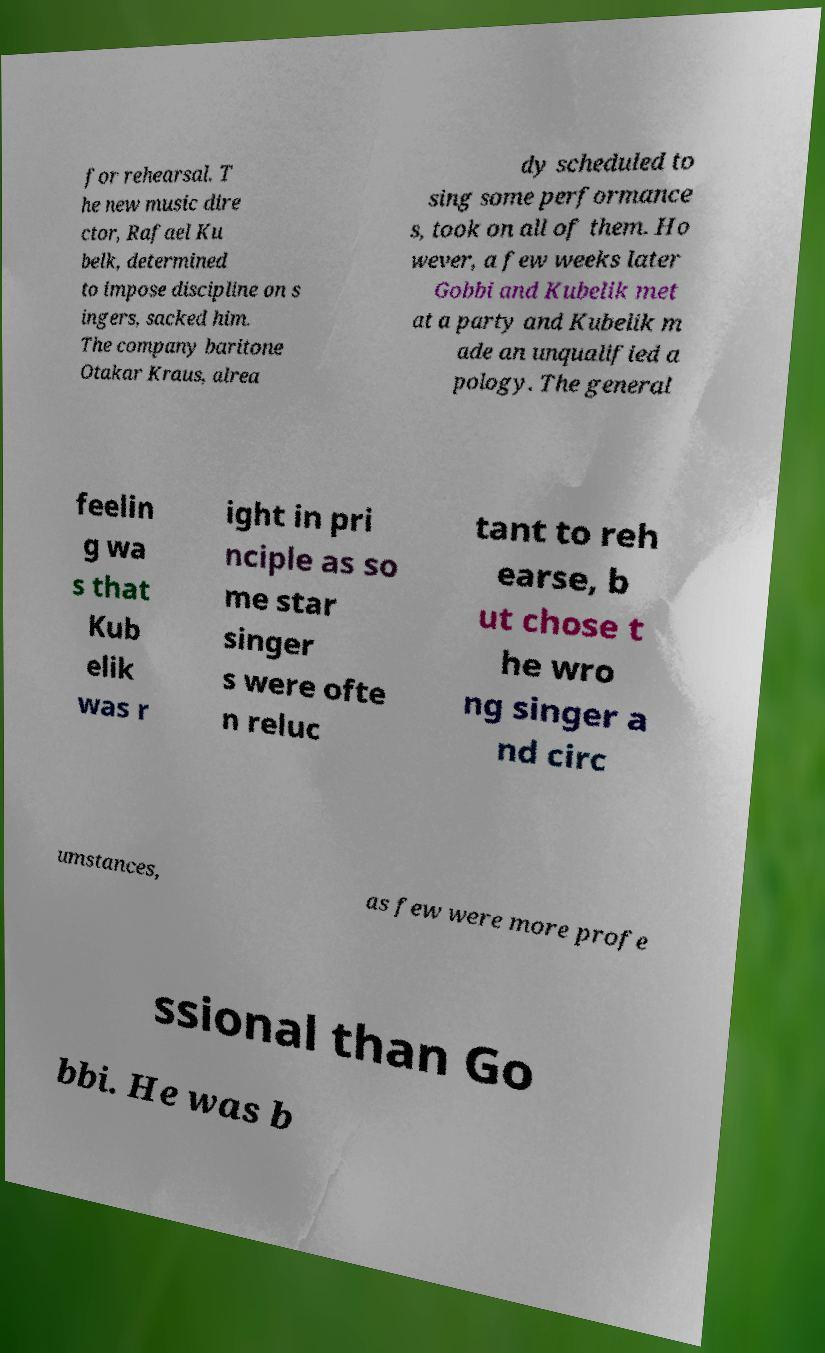Please identify and transcribe the text found in this image. for rehearsal. T he new music dire ctor, Rafael Ku belk, determined to impose discipline on s ingers, sacked him. The company baritone Otakar Kraus, alrea dy scheduled to sing some performance s, took on all of them. Ho wever, a few weeks later Gobbi and Kubelik met at a party and Kubelik m ade an unqualified a pology. The general feelin g wa s that Kub elik was r ight in pri nciple as so me star singer s were ofte n reluc tant to reh earse, b ut chose t he wro ng singer a nd circ umstances, as few were more profe ssional than Go bbi. He was b 